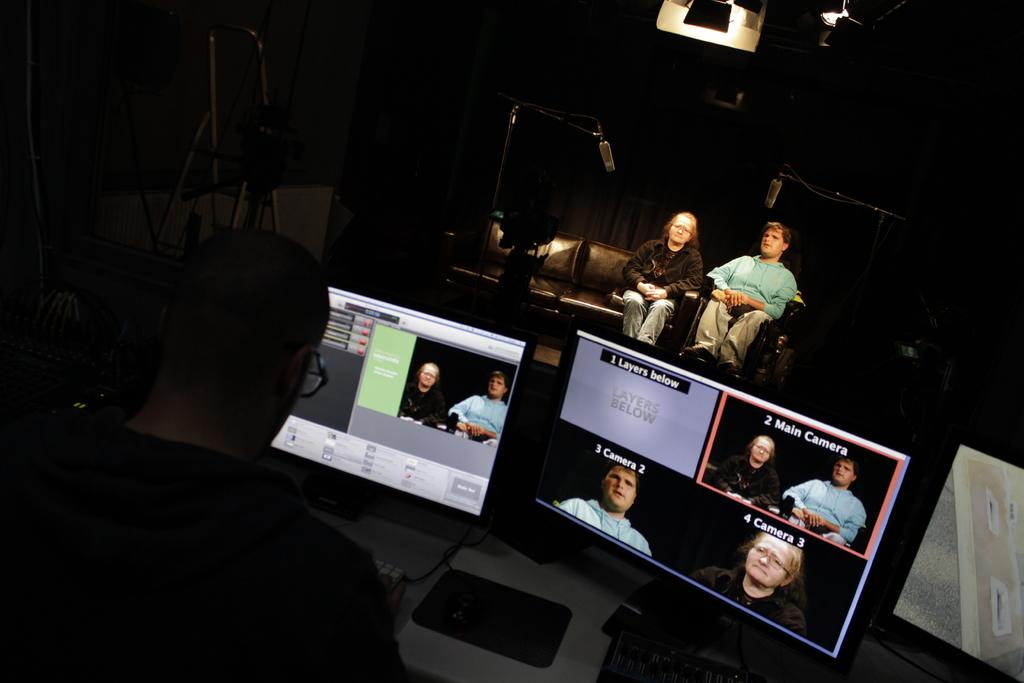<image>
Create a compact narrative representing the image presented. A monitor divided into four panels, the top right panel contains the text "2 Main Camera". 